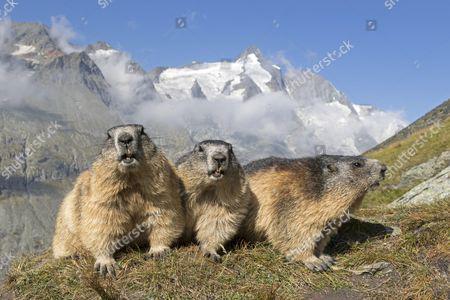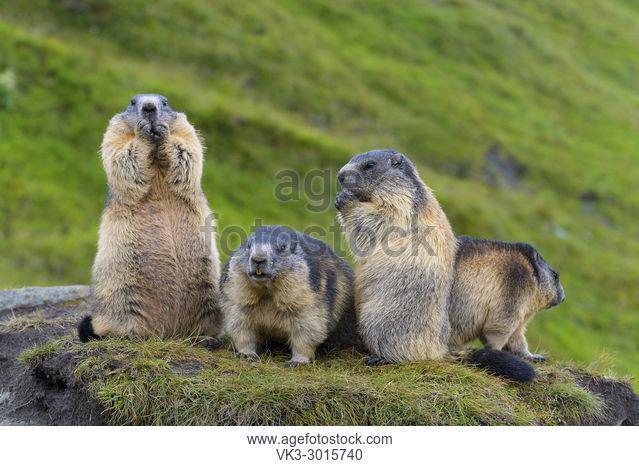The first image is the image on the left, the second image is the image on the right. For the images shown, is this caption "There are more animals in the image on the left." true? Answer yes or no. No. The first image is the image on the left, the second image is the image on the right. For the images displayed, is the sentence "The left image contains 3 marmots, and the right image contains 2 marmots." factually correct? Answer yes or no. No. 